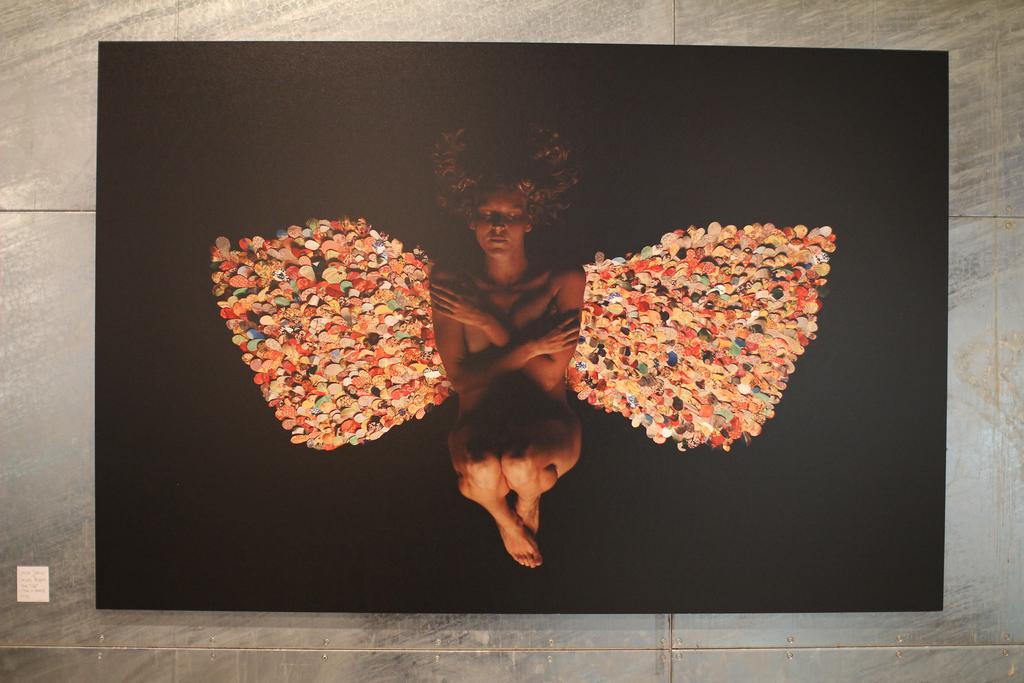Describe this image in one or two sentences. This image consists of a picture, in the middle there is a person. In the background there is a wall, tiles. 